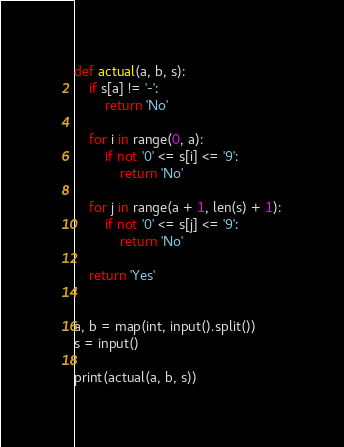<code> <loc_0><loc_0><loc_500><loc_500><_Python_>def actual(a, b, s):
    if s[a] != '-':
        return 'No'

    for i in range(0, a):
        if not '0' <= s[i] <= '9':
            return 'No'

    for j in range(a + 1, len(s) + 1):
        if not '0' <= s[j] <= '9':
            return 'No'

    return 'Yes'


a, b = map(int, input().split())
s = input()

print(actual(a, b, s))
</code> 